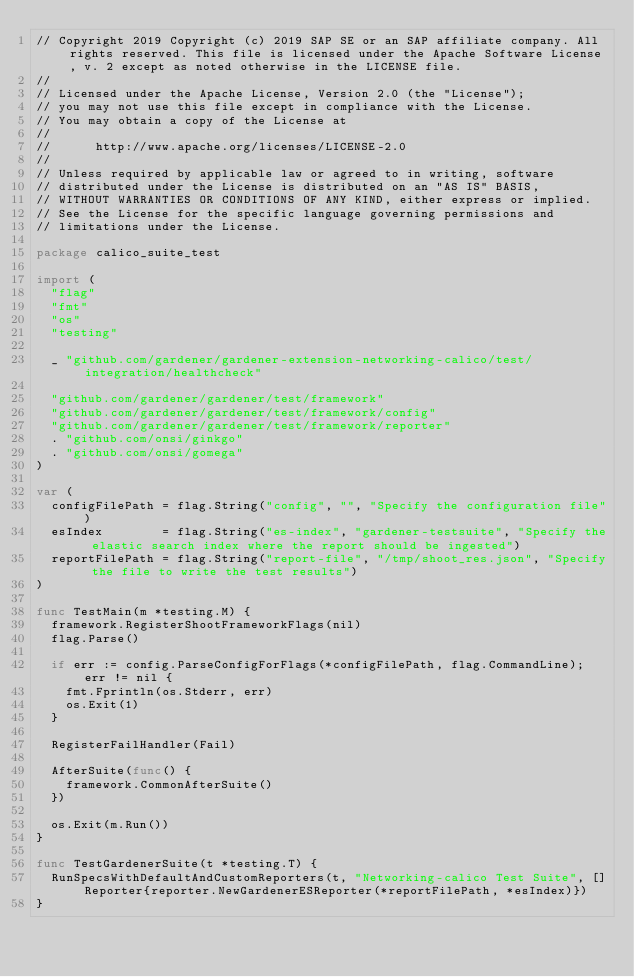<code> <loc_0><loc_0><loc_500><loc_500><_Go_>// Copyright 2019 Copyright (c) 2019 SAP SE or an SAP affiliate company. All rights reserved. This file is licensed under the Apache Software License, v. 2 except as noted otherwise in the LICENSE file.
//
// Licensed under the Apache License, Version 2.0 (the "License");
// you may not use this file except in compliance with the License.
// You may obtain a copy of the License at
//
//      http://www.apache.org/licenses/LICENSE-2.0
//
// Unless required by applicable law or agreed to in writing, software
// distributed under the License is distributed on an "AS IS" BASIS,
// WITHOUT WARRANTIES OR CONDITIONS OF ANY KIND, either express or implied.
// See the License for the specific language governing permissions and
// limitations under the License.

package calico_suite_test

import (
	"flag"
	"fmt"
	"os"
	"testing"

	_ "github.com/gardener/gardener-extension-networking-calico/test/integration/healthcheck"

	"github.com/gardener/gardener/test/framework"
	"github.com/gardener/gardener/test/framework/config"
	"github.com/gardener/gardener/test/framework/reporter"
	. "github.com/onsi/ginkgo"
	. "github.com/onsi/gomega"
)

var (
	configFilePath = flag.String("config", "", "Specify the configuration file")
	esIndex        = flag.String("es-index", "gardener-testsuite", "Specify the elastic search index where the report should be ingested")
	reportFilePath = flag.String("report-file", "/tmp/shoot_res.json", "Specify the file to write the test results")
)

func TestMain(m *testing.M) {
	framework.RegisterShootFrameworkFlags(nil)
	flag.Parse()

	if err := config.ParseConfigForFlags(*configFilePath, flag.CommandLine); err != nil {
		fmt.Fprintln(os.Stderr, err)
		os.Exit(1)
	}

	RegisterFailHandler(Fail)

	AfterSuite(func() {
		framework.CommonAfterSuite()
	})

	os.Exit(m.Run())
}

func TestGardenerSuite(t *testing.T) {
	RunSpecsWithDefaultAndCustomReporters(t, "Networking-calico Test Suite", []Reporter{reporter.NewGardenerESReporter(*reportFilePath, *esIndex)})
}
</code> 